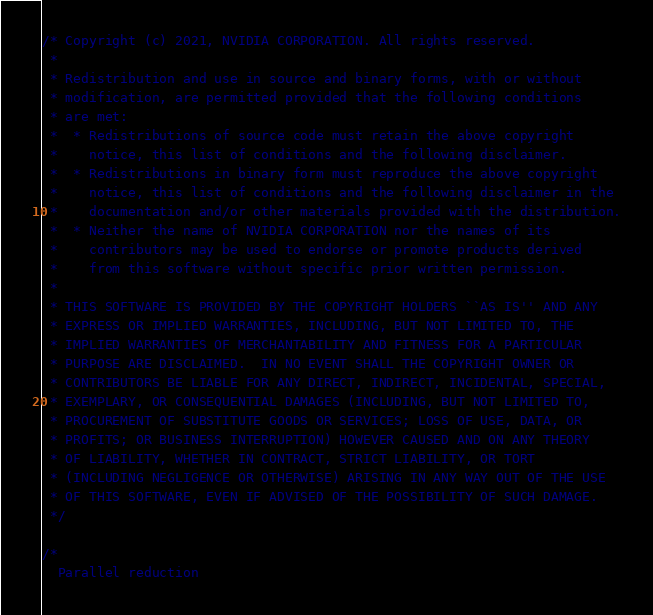<code> <loc_0><loc_0><loc_500><loc_500><_Cuda_>/* Copyright (c) 2021, NVIDIA CORPORATION. All rights reserved.
 *
 * Redistribution and use in source and binary forms, with or without
 * modification, are permitted provided that the following conditions
 * are met:
 *  * Redistributions of source code must retain the above copyright
 *    notice, this list of conditions and the following disclaimer.
 *  * Redistributions in binary form must reproduce the above copyright
 *    notice, this list of conditions and the following disclaimer in the
 *    documentation and/or other materials provided with the distribution.
 *  * Neither the name of NVIDIA CORPORATION nor the names of its
 *    contributors may be used to endorse or promote products derived
 *    from this software without specific prior written permission.
 *
 * THIS SOFTWARE IS PROVIDED BY THE COPYRIGHT HOLDERS ``AS IS'' AND ANY
 * EXPRESS OR IMPLIED WARRANTIES, INCLUDING, BUT NOT LIMITED TO, THE
 * IMPLIED WARRANTIES OF MERCHANTABILITY AND FITNESS FOR A PARTICULAR
 * PURPOSE ARE DISCLAIMED.  IN NO EVENT SHALL THE COPYRIGHT OWNER OR
 * CONTRIBUTORS BE LIABLE FOR ANY DIRECT, INDIRECT, INCIDENTAL, SPECIAL,
 * EXEMPLARY, OR CONSEQUENTIAL DAMAGES (INCLUDING, BUT NOT LIMITED TO,
 * PROCUREMENT OF SUBSTITUTE GOODS OR SERVICES; LOSS OF USE, DATA, OR
 * PROFITS; OR BUSINESS INTERRUPTION) HOWEVER CAUSED AND ON ANY THEORY
 * OF LIABILITY, WHETHER IN CONTRACT, STRICT LIABILITY, OR TORT
 * (INCLUDING NEGLIGENCE OR OTHERWISE) ARISING IN ANY WAY OUT OF THE USE
 * OF THIS SOFTWARE, EVEN IF ADVISED OF THE POSSIBILITY OF SUCH DAMAGE.
 */

/*
  Parallel reduction
</code> 